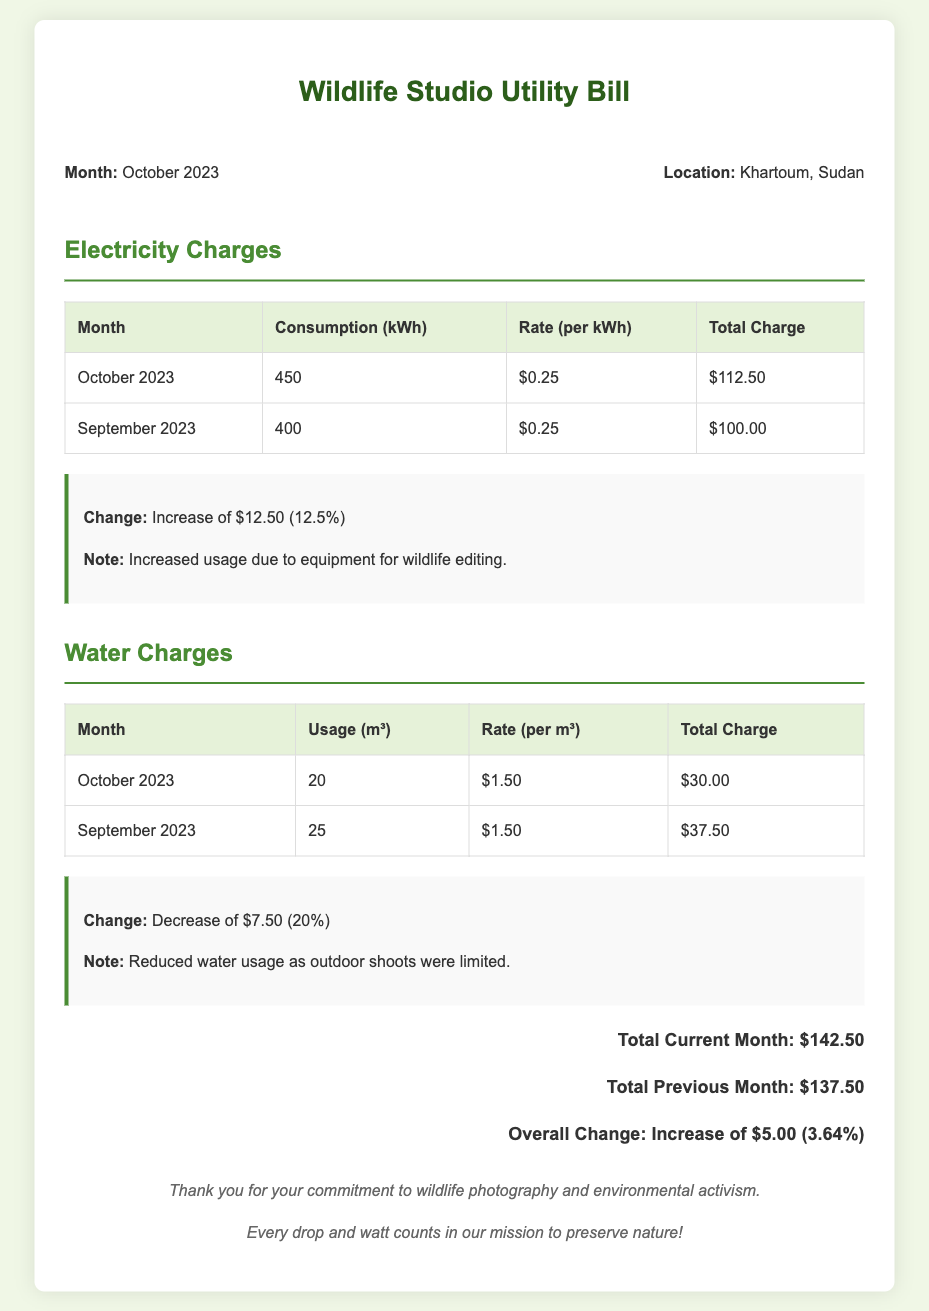What is the total electricity charge for October 2023? The total electricity charge for October 2023 is explicitly stated in the document as $112.50.
Answer: $112.50 What was the water usage in October 2023? The document indicates the water usage for October 2023 as 20 m³.
Answer: 20 m³ What is the percentage increase in electricity charges compared to September 2023? The document specifies an increase of $12.50 which is 12.5%, indicating the percentage change in electricity charges.
Answer: 12.5% What is the total charge for September 2023? The total charge for September 2023 is mentioned in the document as $137.50 for all utilities combined.
Answer: $137.50 What was the water charge rate per cubic meter in October 2023? According to the document, the water charge rate for October 2023 is $1.50 per m³.
Answer: $1.50 What is the overall percentage change in total charges from September to October 2023? The document states there is an overall increase of $5.00 which is 3.64%, thus calculating the percentage change in total charges.
Answer: 3.64% What was the total charge for water usage in September 2023? The document clearly states that the total charge for water usage in September 2023 was $37.50.
Answer: $37.50 How many kilowatt-hours were consumed in October 2023? The document records the electricity consumption for October 2023 as 450 kWh.
Answer: 450 kWh 